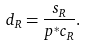Convert formula to latex. <formula><loc_0><loc_0><loc_500><loc_500>d _ { R } = \frac { s _ { R } } { p ^ { * } c _ { R } } .</formula> 